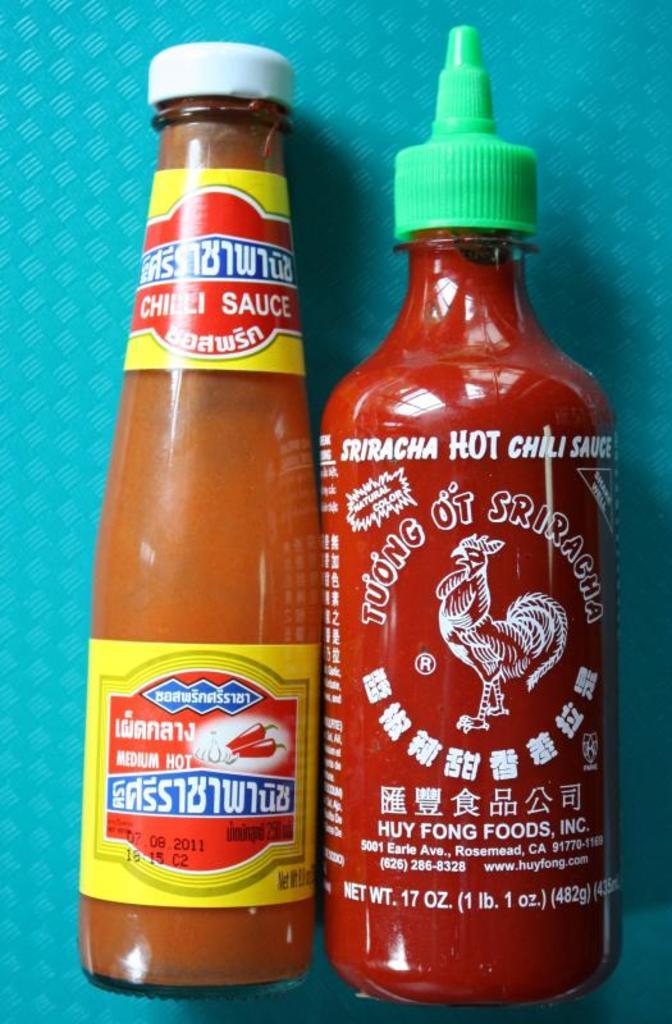How much hot sauce is in the bottle on the right?
Your answer should be compact. 17 oz. What is the volume of the sauce on the right?
Your response must be concise. 17 oz. 